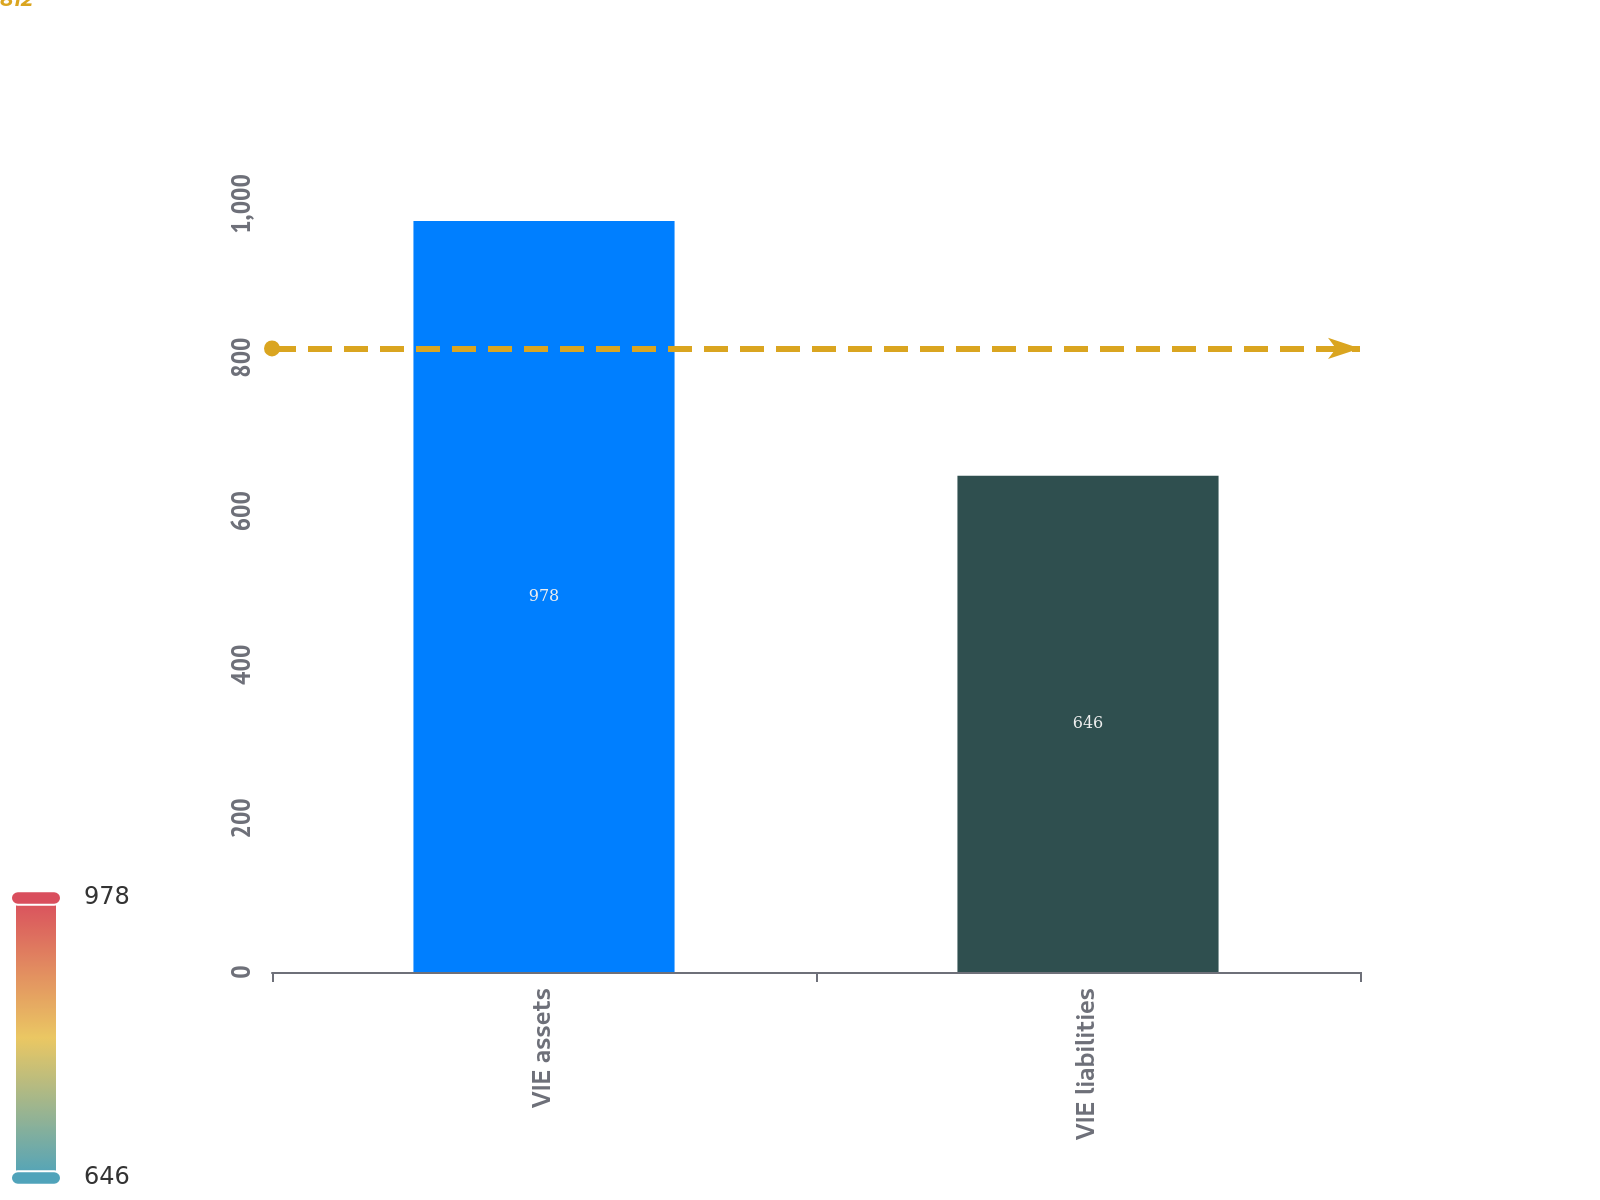Convert chart. <chart><loc_0><loc_0><loc_500><loc_500><bar_chart><fcel>VIE assets<fcel>VIE liabilities<nl><fcel>978<fcel>646<nl></chart> 